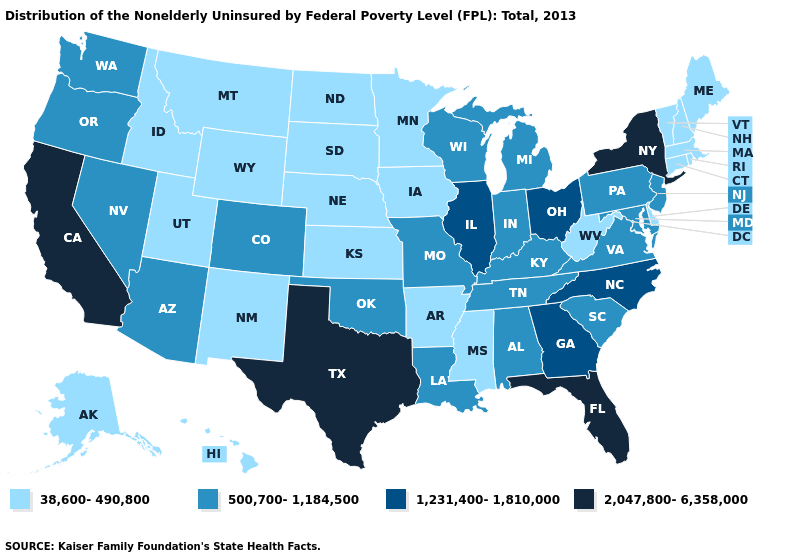Which states hav the highest value in the West?
Keep it brief. California. What is the value of Mississippi?
Short answer required. 38,600-490,800. Does Idaho have the lowest value in the West?
Quick response, please. Yes. Is the legend a continuous bar?
Keep it brief. No. Name the states that have a value in the range 1,231,400-1,810,000?
Short answer required. Georgia, Illinois, North Carolina, Ohio. Which states have the lowest value in the Northeast?
Give a very brief answer. Connecticut, Maine, Massachusetts, New Hampshire, Rhode Island, Vermont. What is the value of Maine?
Concise answer only. 38,600-490,800. How many symbols are there in the legend?
Short answer required. 4. Name the states that have a value in the range 38,600-490,800?
Short answer required. Alaska, Arkansas, Connecticut, Delaware, Hawaii, Idaho, Iowa, Kansas, Maine, Massachusetts, Minnesota, Mississippi, Montana, Nebraska, New Hampshire, New Mexico, North Dakota, Rhode Island, South Dakota, Utah, Vermont, West Virginia, Wyoming. What is the highest value in the USA?
Quick response, please. 2,047,800-6,358,000. Does the first symbol in the legend represent the smallest category?
Quick response, please. Yes. What is the value of Tennessee?
Be succinct. 500,700-1,184,500. What is the highest value in states that border Louisiana?
Answer briefly. 2,047,800-6,358,000. Which states have the lowest value in the West?
Short answer required. Alaska, Hawaii, Idaho, Montana, New Mexico, Utah, Wyoming. Does Tennessee have a higher value than New Hampshire?
Answer briefly. Yes. 